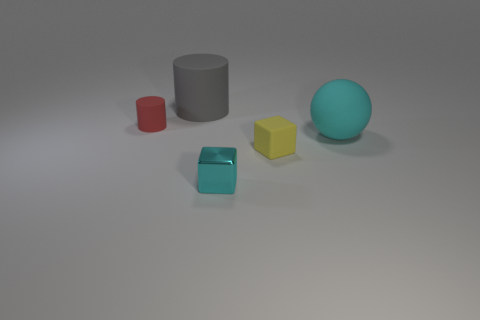Add 4 cylinders. How many objects exist? 9 Subtract all cylinders. How many objects are left? 3 Subtract all brown blocks. Subtract all green balls. How many blocks are left? 2 Subtract all purple balls. How many yellow blocks are left? 1 Subtract all yellow cubes. Subtract all big cylinders. How many objects are left? 3 Add 2 metal blocks. How many metal blocks are left? 3 Add 5 small yellow objects. How many small yellow objects exist? 6 Subtract all red cylinders. How many cylinders are left? 1 Subtract 0 brown cylinders. How many objects are left? 5 Subtract 1 cylinders. How many cylinders are left? 1 